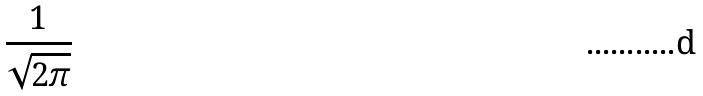<formula> <loc_0><loc_0><loc_500><loc_500>\frac { 1 } { \sqrt { 2 \pi } }</formula> 